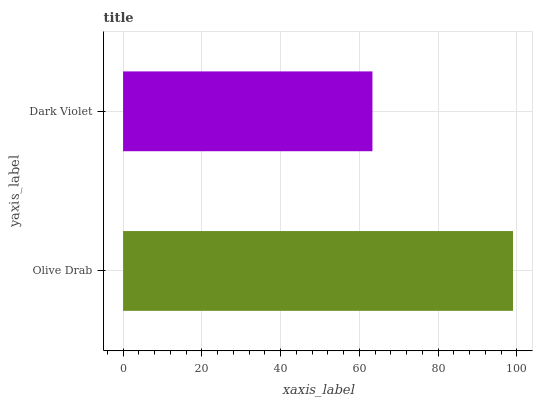Is Dark Violet the minimum?
Answer yes or no. Yes. Is Olive Drab the maximum?
Answer yes or no. Yes. Is Dark Violet the maximum?
Answer yes or no. No. Is Olive Drab greater than Dark Violet?
Answer yes or no. Yes. Is Dark Violet less than Olive Drab?
Answer yes or no. Yes. Is Dark Violet greater than Olive Drab?
Answer yes or no. No. Is Olive Drab less than Dark Violet?
Answer yes or no. No. Is Olive Drab the high median?
Answer yes or no. Yes. Is Dark Violet the low median?
Answer yes or no. Yes. Is Dark Violet the high median?
Answer yes or no. No. Is Olive Drab the low median?
Answer yes or no. No. 